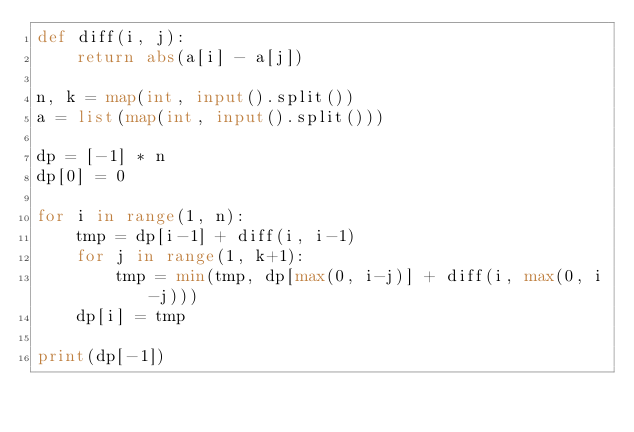<code> <loc_0><loc_0><loc_500><loc_500><_Python_>def diff(i, j):
    return abs(a[i] - a[j])
    
n, k = map(int, input().split())
a = list(map(int, input().split()))

dp = [-1] * n
dp[0] = 0

for i in range(1, n):
    tmp = dp[i-1] + diff(i, i-1)
    for j in range(1, k+1):
        tmp = min(tmp, dp[max(0, i-j)] + diff(i, max(0, i-j)))
    dp[i] = tmp
    
print(dp[-1])
</code> 